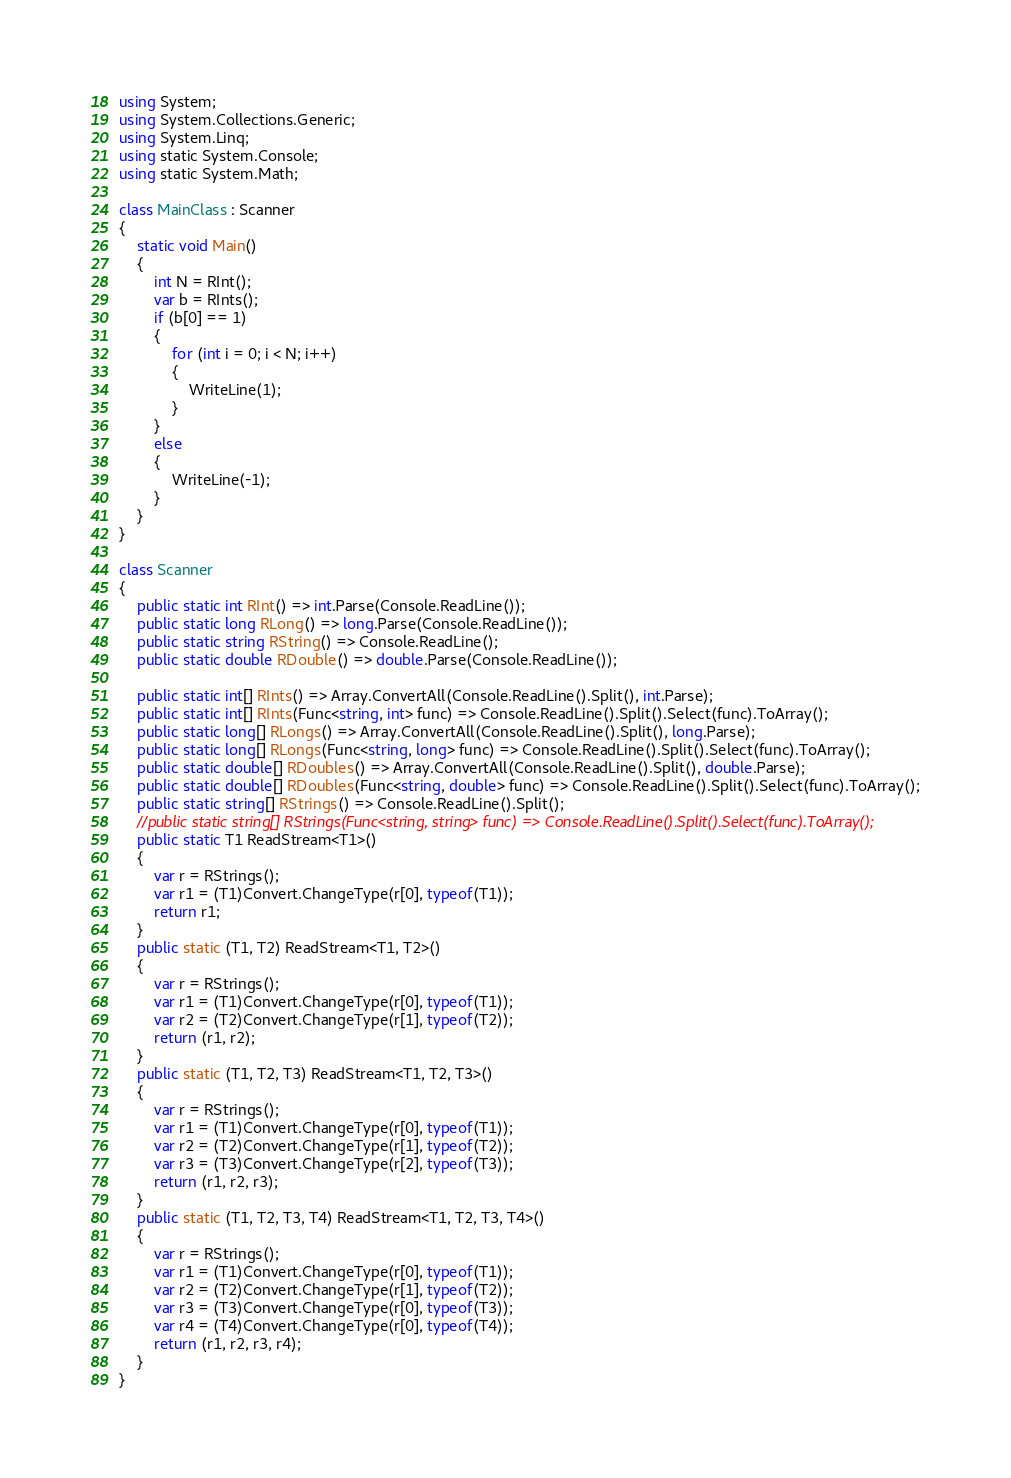<code> <loc_0><loc_0><loc_500><loc_500><_C#_>using System;
using System.Collections.Generic;
using System.Linq;
using static System.Console;
using static System.Math;

class MainClass : Scanner
{
    static void Main()
    {
        int N = RInt();
        var b = RInts();
        if (b[0] == 1)
        {
            for (int i = 0; i < N; i++)
            {
                WriteLine(1);
            }
        }
        else
        {
            WriteLine(-1);
        }
    }
}

class Scanner
{
    public static int RInt() => int.Parse(Console.ReadLine());
    public static long RLong() => long.Parse(Console.ReadLine());
    public static string RString() => Console.ReadLine();
    public static double RDouble() => double.Parse(Console.ReadLine());

    public static int[] RInts() => Array.ConvertAll(Console.ReadLine().Split(), int.Parse);
    public static int[] RInts(Func<string, int> func) => Console.ReadLine().Split().Select(func).ToArray();
    public static long[] RLongs() => Array.ConvertAll(Console.ReadLine().Split(), long.Parse);
    public static long[] RLongs(Func<string, long> func) => Console.ReadLine().Split().Select(func).ToArray();
    public static double[] RDoubles() => Array.ConvertAll(Console.ReadLine().Split(), double.Parse);
    public static double[] RDoubles(Func<string, double> func) => Console.ReadLine().Split().Select(func).ToArray();
    public static string[] RStrings() => Console.ReadLine().Split();
    //public static string[] RStrings(Func<string, string> func) => Console.ReadLine().Split().Select(func).ToArray();
    public static T1 ReadStream<T1>()
    {
        var r = RStrings();
        var r1 = (T1)Convert.ChangeType(r[0], typeof(T1));
        return r1;
    }
    public static (T1, T2) ReadStream<T1, T2>()
    {
        var r = RStrings();
        var r1 = (T1)Convert.ChangeType(r[0], typeof(T1));
        var r2 = (T2)Convert.ChangeType(r[1], typeof(T2));
        return (r1, r2);
    }
    public static (T1, T2, T3) ReadStream<T1, T2, T3>()
    {
        var r = RStrings();
        var r1 = (T1)Convert.ChangeType(r[0], typeof(T1));
        var r2 = (T2)Convert.ChangeType(r[1], typeof(T2));
        var r3 = (T3)Convert.ChangeType(r[2], typeof(T3));
        return (r1, r2, r3);
    }
    public static (T1, T2, T3, T4) ReadStream<T1, T2, T3, T4>()
    {
        var r = RStrings();
        var r1 = (T1)Convert.ChangeType(r[0], typeof(T1));
        var r2 = (T2)Convert.ChangeType(r[1], typeof(T2));
        var r3 = (T3)Convert.ChangeType(r[0], typeof(T3));
        var r4 = (T4)Convert.ChangeType(r[0], typeof(T4));
        return (r1, r2, r3, r4);
    }
}</code> 